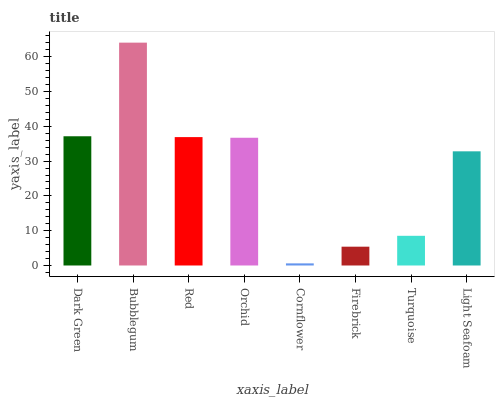Is Cornflower the minimum?
Answer yes or no. Yes. Is Bubblegum the maximum?
Answer yes or no. Yes. Is Red the minimum?
Answer yes or no. No. Is Red the maximum?
Answer yes or no. No. Is Bubblegum greater than Red?
Answer yes or no. Yes. Is Red less than Bubblegum?
Answer yes or no. Yes. Is Red greater than Bubblegum?
Answer yes or no. No. Is Bubblegum less than Red?
Answer yes or no. No. Is Orchid the high median?
Answer yes or no. Yes. Is Light Seafoam the low median?
Answer yes or no. Yes. Is Red the high median?
Answer yes or no. No. Is Red the low median?
Answer yes or no. No. 